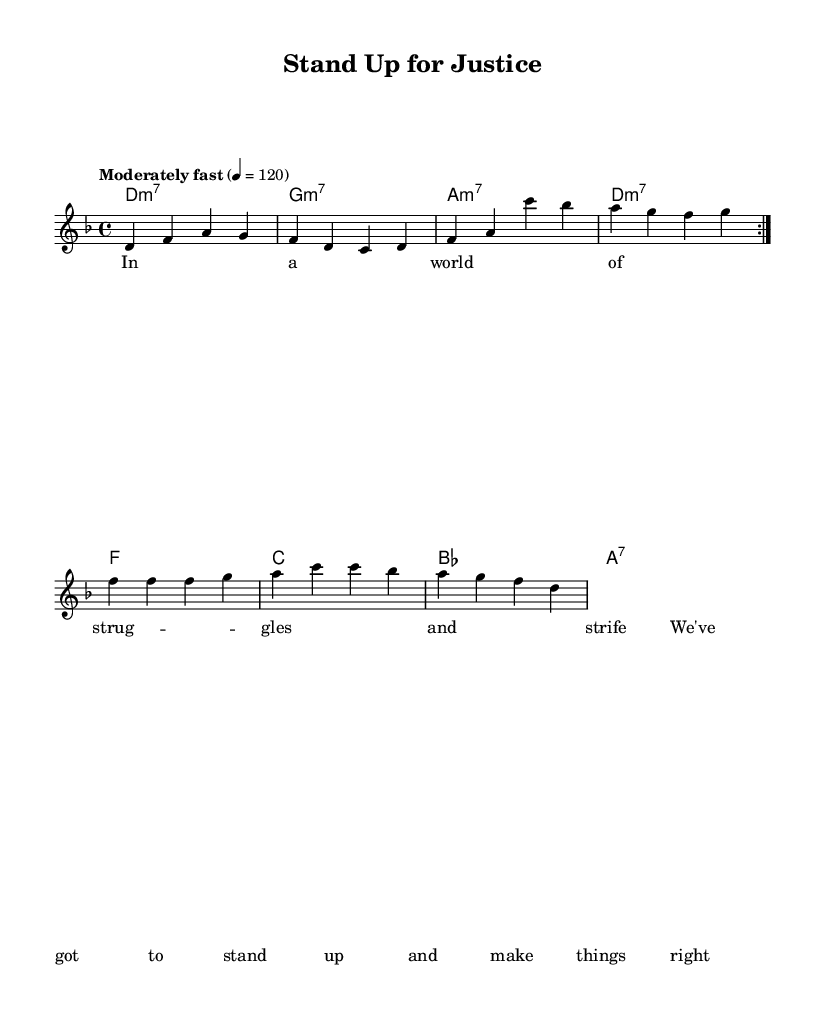What is the key signature of this music? The key signature shows two flats, indicating that the music is in the key of D minor.
Answer: D minor What is the time signature of this piece? The time signature is 4/4, which means there are four beats in a measure and a quarter note receives one beat.
Answer: 4/4 What is the tempo marking for this composition? The tempo marking indicates "Moderately fast" at a metronome marking of 120 beats per minute, guiding performers on the desired speed.
Answer: Moderately fast, 120 How many measures are in the verse section? The verse section has 4 measures as indicated by the grouping of the notes in that part of the music. Each separate grouping indicates a new measure.
Answer: 4 What is the first chord of the chorus? The first chord in the chorus is a D minor 7 chord, as shown in the harmonization before the lyrics.
Answer: D minor 7 What lyrical theme does the song promote? The lyrics focus on standing up for justice and equality, which reflects the social justice themes present throughout the piece.
Answer: Justice and Equality Which part repeats in the structure of this music? The melody section marked with "volta 2" specifies that the entire section should be repeated two times, indicating its importance in the song's structure.
Answer: Melody 